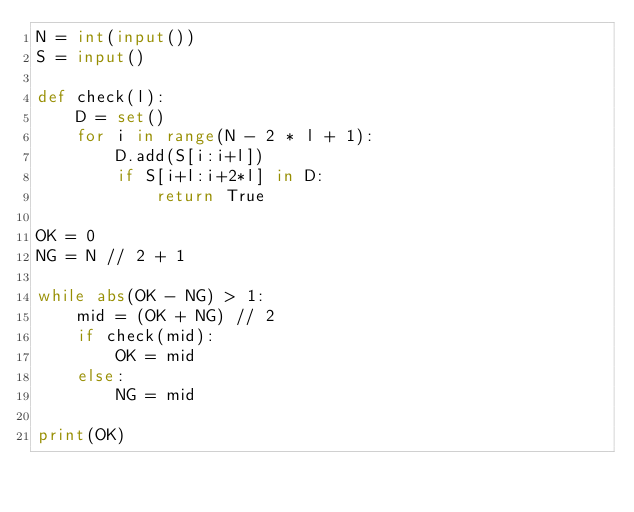<code> <loc_0><loc_0><loc_500><loc_500><_Python_>N = int(input())
S = input()

def check(l):
    D = set()
    for i in range(N - 2 * l + 1):
        D.add(S[i:i+l])
        if S[i+l:i+2*l] in D:
            return True

OK = 0
NG = N // 2 + 1

while abs(OK - NG) > 1:
    mid = (OK + NG) // 2
    if check(mid):
        OK = mid
    else:
        NG = mid

print(OK)</code> 